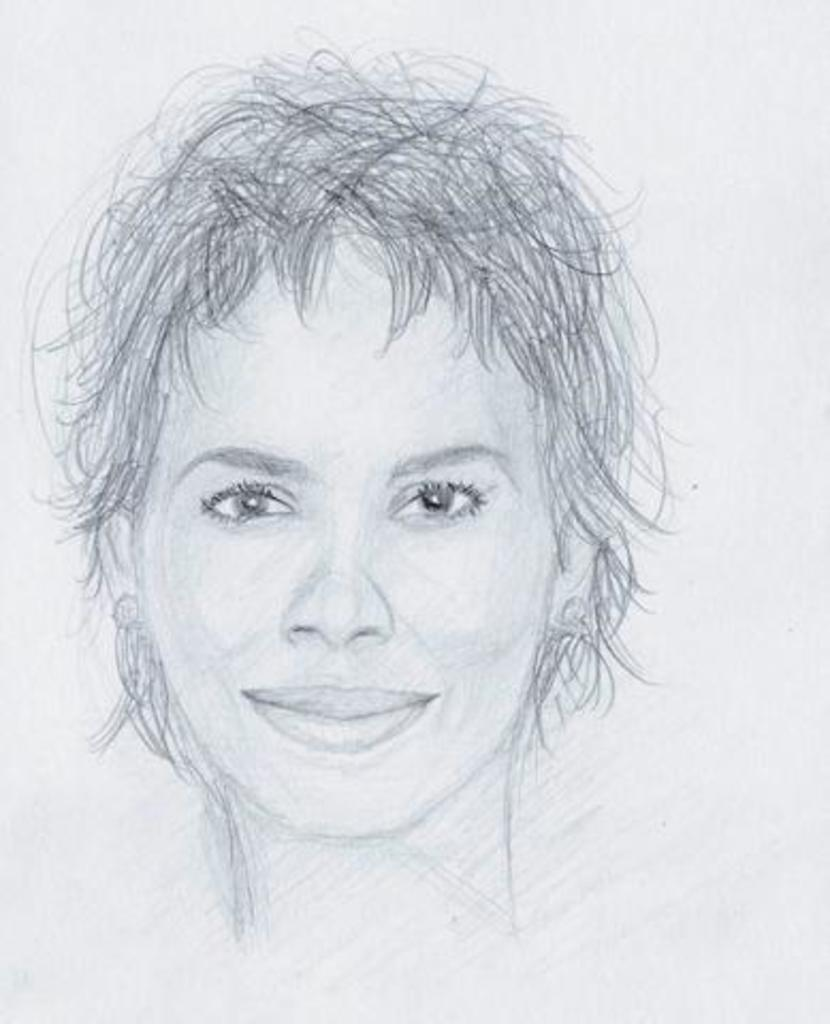What type of image is shown in the picture? The image is a sketch. What is the main subject of the sketch? There is a lady depicted in the sketch. What type of leaf is falling from the lady's hair in the sketch? There is no leaf or any indication of a leaf falling from the lady's hair in the sketch. 